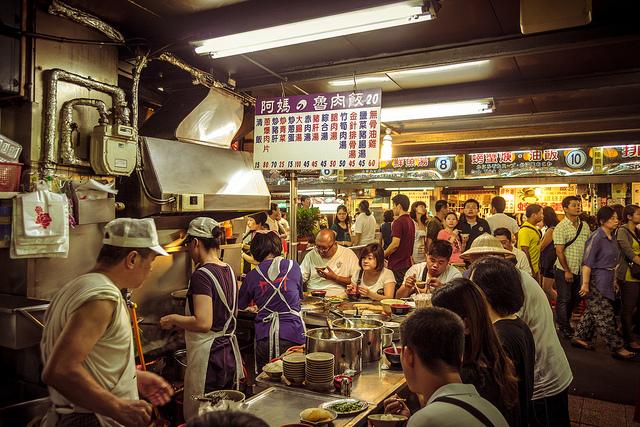What is on the table?
Keep it brief. Food. What is the predominant color of hate?
Keep it brief. Red. Is this photo clear?
Answer briefly. Yes. What color are the cooks wearing?
Give a very brief answer. Purple. What area are they in?
Short answer required. Kitchen. 